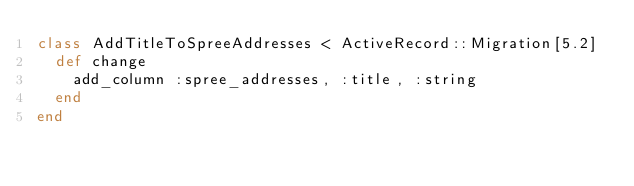Convert code to text. <code><loc_0><loc_0><loc_500><loc_500><_Ruby_>class AddTitleToSpreeAddresses < ActiveRecord::Migration[5.2]
  def change
    add_column :spree_addresses, :title, :string
  end
end
</code> 